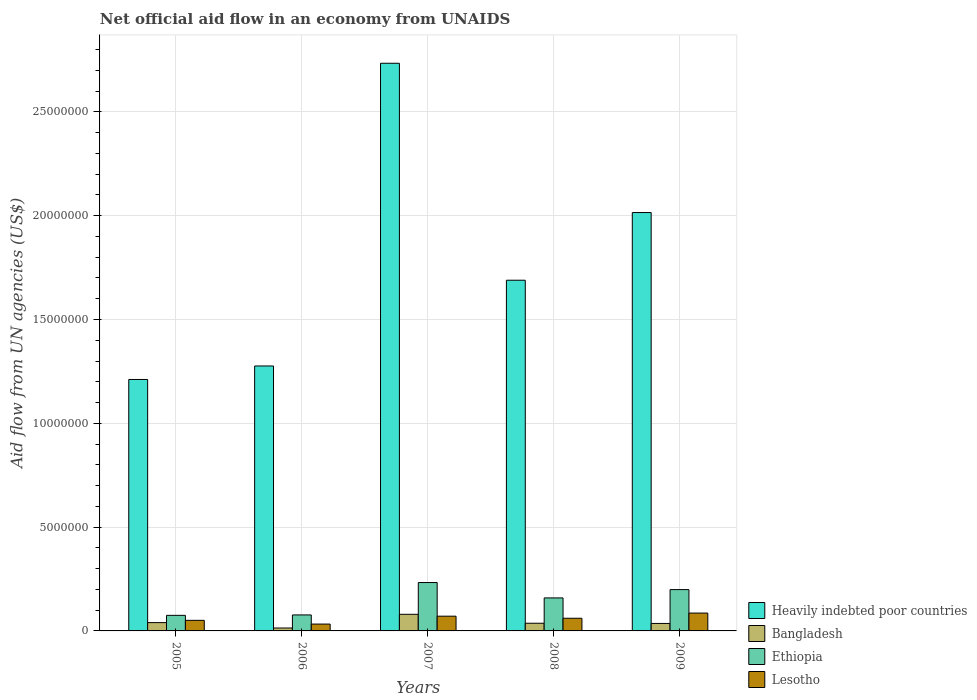What is the label of the 1st group of bars from the left?
Provide a short and direct response. 2005. In how many cases, is the number of bars for a given year not equal to the number of legend labels?
Your answer should be very brief. 0. What is the net official aid flow in Ethiopia in 2008?
Provide a short and direct response. 1.59e+06. Across all years, what is the maximum net official aid flow in Heavily indebted poor countries?
Give a very brief answer. 2.73e+07. Across all years, what is the minimum net official aid flow in Bangladesh?
Provide a succinct answer. 1.40e+05. In which year was the net official aid flow in Lesotho minimum?
Offer a terse response. 2006. What is the total net official aid flow in Heavily indebted poor countries in the graph?
Keep it short and to the point. 8.92e+07. What is the difference between the net official aid flow in Heavily indebted poor countries in 2005 and that in 2006?
Give a very brief answer. -6.50e+05. What is the difference between the net official aid flow in Heavily indebted poor countries in 2005 and the net official aid flow in Bangladesh in 2009?
Provide a short and direct response. 1.18e+07. What is the average net official aid flow in Lesotho per year?
Your answer should be very brief. 6.04e+05. In the year 2008, what is the difference between the net official aid flow in Heavily indebted poor countries and net official aid flow in Bangladesh?
Your answer should be very brief. 1.65e+07. In how many years, is the net official aid flow in Bangladesh greater than 13000000 US$?
Make the answer very short. 0. What is the ratio of the net official aid flow in Ethiopia in 2005 to that in 2009?
Offer a terse response. 0.38. Is the net official aid flow in Ethiopia in 2006 less than that in 2007?
Ensure brevity in your answer.  Yes. What is the difference between the highest and the second highest net official aid flow in Ethiopia?
Offer a terse response. 3.40e+05. What is the difference between the highest and the lowest net official aid flow in Ethiopia?
Your answer should be compact. 1.58e+06. Is the sum of the net official aid flow in Heavily indebted poor countries in 2005 and 2007 greater than the maximum net official aid flow in Lesotho across all years?
Offer a terse response. Yes. Is it the case that in every year, the sum of the net official aid flow in Heavily indebted poor countries and net official aid flow in Lesotho is greater than the sum of net official aid flow in Ethiopia and net official aid flow in Bangladesh?
Ensure brevity in your answer.  Yes. What does the 3rd bar from the left in 2005 represents?
Provide a short and direct response. Ethiopia. What does the 2nd bar from the right in 2006 represents?
Make the answer very short. Ethiopia. How many bars are there?
Provide a short and direct response. 20. What is the difference between two consecutive major ticks on the Y-axis?
Provide a succinct answer. 5.00e+06. Does the graph contain any zero values?
Offer a terse response. No. Does the graph contain grids?
Ensure brevity in your answer.  Yes. Where does the legend appear in the graph?
Provide a succinct answer. Bottom right. How are the legend labels stacked?
Offer a very short reply. Vertical. What is the title of the graph?
Keep it short and to the point. Net official aid flow in an economy from UNAIDS. Does "Guinea" appear as one of the legend labels in the graph?
Give a very brief answer. No. What is the label or title of the Y-axis?
Offer a very short reply. Aid flow from UN agencies (US$). What is the Aid flow from UN agencies (US$) in Heavily indebted poor countries in 2005?
Ensure brevity in your answer.  1.21e+07. What is the Aid flow from UN agencies (US$) of Bangladesh in 2005?
Provide a short and direct response. 4.00e+05. What is the Aid flow from UN agencies (US$) of Ethiopia in 2005?
Offer a terse response. 7.50e+05. What is the Aid flow from UN agencies (US$) in Lesotho in 2005?
Keep it short and to the point. 5.10e+05. What is the Aid flow from UN agencies (US$) in Heavily indebted poor countries in 2006?
Provide a succinct answer. 1.28e+07. What is the Aid flow from UN agencies (US$) in Ethiopia in 2006?
Offer a terse response. 7.70e+05. What is the Aid flow from UN agencies (US$) in Heavily indebted poor countries in 2007?
Offer a very short reply. 2.73e+07. What is the Aid flow from UN agencies (US$) of Ethiopia in 2007?
Your answer should be very brief. 2.33e+06. What is the Aid flow from UN agencies (US$) in Lesotho in 2007?
Provide a short and direct response. 7.10e+05. What is the Aid flow from UN agencies (US$) in Heavily indebted poor countries in 2008?
Provide a succinct answer. 1.69e+07. What is the Aid flow from UN agencies (US$) in Ethiopia in 2008?
Your response must be concise. 1.59e+06. What is the Aid flow from UN agencies (US$) in Lesotho in 2008?
Give a very brief answer. 6.10e+05. What is the Aid flow from UN agencies (US$) in Heavily indebted poor countries in 2009?
Make the answer very short. 2.02e+07. What is the Aid flow from UN agencies (US$) in Ethiopia in 2009?
Your response must be concise. 1.99e+06. What is the Aid flow from UN agencies (US$) of Lesotho in 2009?
Your answer should be very brief. 8.60e+05. Across all years, what is the maximum Aid flow from UN agencies (US$) of Heavily indebted poor countries?
Ensure brevity in your answer.  2.73e+07. Across all years, what is the maximum Aid flow from UN agencies (US$) in Ethiopia?
Your answer should be very brief. 2.33e+06. Across all years, what is the maximum Aid flow from UN agencies (US$) of Lesotho?
Your answer should be compact. 8.60e+05. Across all years, what is the minimum Aid flow from UN agencies (US$) in Heavily indebted poor countries?
Your answer should be compact. 1.21e+07. Across all years, what is the minimum Aid flow from UN agencies (US$) in Ethiopia?
Give a very brief answer. 7.50e+05. What is the total Aid flow from UN agencies (US$) of Heavily indebted poor countries in the graph?
Provide a succinct answer. 8.92e+07. What is the total Aid flow from UN agencies (US$) in Bangladesh in the graph?
Ensure brevity in your answer.  2.07e+06. What is the total Aid flow from UN agencies (US$) of Ethiopia in the graph?
Give a very brief answer. 7.43e+06. What is the total Aid flow from UN agencies (US$) of Lesotho in the graph?
Provide a succinct answer. 3.02e+06. What is the difference between the Aid flow from UN agencies (US$) in Heavily indebted poor countries in 2005 and that in 2006?
Ensure brevity in your answer.  -6.50e+05. What is the difference between the Aid flow from UN agencies (US$) in Bangladesh in 2005 and that in 2006?
Ensure brevity in your answer.  2.60e+05. What is the difference between the Aid flow from UN agencies (US$) in Ethiopia in 2005 and that in 2006?
Give a very brief answer. -2.00e+04. What is the difference between the Aid flow from UN agencies (US$) of Heavily indebted poor countries in 2005 and that in 2007?
Give a very brief answer. -1.52e+07. What is the difference between the Aid flow from UN agencies (US$) of Bangladesh in 2005 and that in 2007?
Keep it short and to the point. -4.00e+05. What is the difference between the Aid flow from UN agencies (US$) in Ethiopia in 2005 and that in 2007?
Your answer should be compact. -1.58e+06. What is the difference between the Aid flow from UN agencies (US$) in Lesotho in 2005 and that in 2007?
Provide a short and direct response. -2.00e+05. What is the difference between the Aid flow from UN agencies (US$) in Heavily indebted poor countries in 2005 and that in 2008?
Offer a very short reply. -4.78e+06. What is the difference between the Aid flow from UN agencies (US$) in Bangladesh in 2005 and that in 2008?
Your answer should be compact. 3.00e+04. What is the difference between the Aid flow from UN agencies (US$) in Ethiopia in 2005 and that in 2008?
Ensure brevity in your answer.  -8.40e+05. What is the difference between the Aid flow from UN agencies (US$) of Lesotho in 2005 and that in 2008?
Keep it short and to the point. -1.00e+05. What is the difference between the Aid flow from UN agencies (US$) in Heavily indebted poor countries in 2005 and that in 2009?
Ensure brevity in your answer.  -8.04e+06. What is the difference between the Aid flow from UN agencies (US$) of Ethiopia in 2005 and that in 2009?
Provide a succinct answer. -1.24e+06. What is the difference between the Aid flow from UN agencies (US$) of Lesotho in 2005 and that in 2009?
Give a very brief answer. -3.50e+05. What is the difference between the Aid flow from UN agencies (US$) of Heavily indebted poor countries in 2006 and that in 2007?
Keep it short and to the point. -1.46e+07. What is the difference between the Aid flow from UN agencies (US$) in Bangladesh in 2006 and that in 2007?
Offer a terse response. -6.60e+05. What is the difference between the Aid flow from UN agencies (US$) in Ethiopia in 2006 and that in 2007?
Provide a succinct answer. -1.56e+06. What is the difference between the Aid flow from UN agencies (US$) of Lesotho in 2006 and that in 2007?
Make the answer very short. -3.80e+05. What is the difference between the Aid flow from UN agencies (US$) in Heavily indebted poor countries in 2006 and that in 2008?
Your response must be concise. -4.13e+06. What is the difference between the Aid flow from UN agencies (US$) of Bangladesh in 2006 and that in 2008?
Your response must be concise. -2.30e+05. What is the difference between the Aid flow from UN agencies (US$) in Ethiopia in 2006 and that in 2008?
Make the answer very short. -8.20e+05. What is the difference between the Aid flow from UN agencies (US$) of Lesotho in 2006 and that in 2008?
Give a very brief answer. -2.80e+05. What is the difference between the Aid flow from UN agencies (US$) in Heavily indebted poor countries in 2006 and that in 2009?
Give a very brief answer. -7.39e+06. What is the difference between the Aid flow from UN agencies (US$) in Bangladesh in 2006 and that in 2009?
Offer a very short reply. -2.20e+05. What is the difference between the Aid flow from UN agencies (US$) in Ethiopia in 2006 and that in 2009?
Give a very brief answer. -1.22e+06. What is the difference between the Aid flow from UN agencies (US$) in Lesotho in 2006 and that in 2009?
Your response must be concise. -5.30e+05. What is the difference between the Aid flow from UN agencies (US$) of Heavily indebted poor countries in 2007 and that in 2008?
Provide a short and direct response. 1.04e+07. What is the difference between the Aid flow from UN agencies (US$) in Bangladesh in 2007 and that in 2008?
Make the answer very short. 4.30e+05. What is the difference between the Aid flow from UN agencies (US$) of Ethiopia in 2007 and that in 2008?
Your answer should be very brief. 7.40e+05. What is the difference between the Aid flow from UN agencies (US$) of Lesotho in 2007 and that in 2008?
Provide a short and direct response. 1.00e+05. What is the difference between the Aid flow from UN agencies (US$) in Heavily indebted poor countries in 2007 and that in 2009?
Your answer should be very brief. 7.19e+06. What is the difference between the Aid flow from UN agencies (US$) in Bangladesh in 2007 and that in 2009?
Make the answer very short. 4.40e+05. What is the difference between the Aid flow from UN agencies (US$) of Ethiopia in 2007 and that in 2009?
Provide a succinct answer. 3.40e+05. What is the difference between the Aid flow from UN agencies (US$) in Heavily indebted poor countries in 2008 and that in 2009?
Keep it short and to the point. -3.26e+06. What is the difference between the Aid flow from UN agencies (US$) of Bangladesh in 2008 and that in 2009?
Offer a terse response. 10000. What is the difference between the Aid flow from UN agencies (US$) of Ethiopia in 2008 and that in 2009?
Your answer should be very brief. -4.00e+05. What is the difference between the Aid flow from UN agencies (US$) of Heavily indebted poor countries in 2005 and the Aid flow from UN agencies (US$) of Bangladesh in 2006?
Your answer should be very brief. 1.20e+07. What is the difference between the Aid flow from UN agencies (US$) of Heavily indebted poor countries in 2005 and the Aid flow from UN agencies (US$) of Ethiopia in 2006?
Make the answer very short. 1.13e+07. What is the difference between the Aid flow from UN agencies (US$) in Heavily indebted poor countries in 2005 and the Aid flow from UN agencies (US$) in Lesotho in 2006?
Your answer should be compact. 1.18e+07. What is the difference between the Aid flow from UN agencies (US$) in Bangladesh in 2005 and the Aid flow from UN agencies (US$) in Ethiopia in 2006?
Your answer should be compact. -3.70e+05. What is the difference between the Aid flow from UN agencies (US$) in Heavily indebted poor countries in 2005 and the Aid flow from UN agencies (US$) in Bangladesh in 2007?
Provide a succinct answer. 1.13e+07. What is the difference between the Aid flow from UN agencies (US$) in Heavily indebted poor countries in 2005 and the Aid flow from UN agencies (US$) in Ethiopia in 2007?
Your response must be concise. 9.78e+06. What is the difference between the Aid flow from UN agencies (US$) of Heavily indebted poor countries in 2005 and the Aid flow from UN agencies (US$) of Lesotho in 2007?
Your answer should be very brief. 1.14e+07. What is the difference between the Aid flow from UN agencies (US$) of Bangladesh in 2005 and the Aid flow from UN agencies (US$) of Ethiopia in 2007?
Give a very brief answer. -1.93e+06. What is the difference between the Aid flow from UN agencies (US$) of Bangladesh in 2005 and the Aid flow from UN agencies (US$) of Lesotho in 2007?
Ensure brevity in your answer.  -3.10e+05. What is the difference between the Aid flow from UN agencies (US$) of Heavily indebted poor countries in 2005 and the Aid flow from UN agencies (US$) of Bangladesh in 2008?
Your answer should be compact. 1.17e+07. What is the difference between the Aid flow from UN agencies (US$) of Heavily indebted poor countries in 2005 and the Aid flow from UN agencies (US$) of Ethiopia in 2008?
Make the answer very short. 1.05e+07. What is the difference between the Aid flow from UN agencies (US$) of Heavily indebted poor countries in 2005 and the Aid flow from UN agencies (US$) of Lesotho in 2008?
Provide a short and direct response. 1.15e+07. What is the difference between the Aid flow from UN agencies (US$) in Bangladesh in 2005 and the Aid flow from UN agencies (US$) in Ethiopia in 2008?
Provide a succinct answer. -1.19e+06. What is the difference between the Aid flow from UN agencies (US$) of Bangladesh in 2005 and the Aid flow from UN agencies (US$) of Lesotho in 2008?
Ensure brevity in your answer.  -2.10e+05. What is the difference between the Aid flow from UN agencies (US$) of Ethiopia in 2005 and the Aid flow from UN agencies (US$) of Lesotho in 2008?
Ensure brevity in your answer.  1.40e+05. What is the difference between the Aid flow from UN agencies (US$) of Heavily indebted poor countries in 2005 and the Aid flow from UN agencies (US$) of Bangladesh in 2009?
Ensure brevity in your answer.  1.18e+07. What is the difference between the Aid flow from UN agencies (US$) of Heavily indebted poor countries in 2005 and the Aid flow from UN agencies (US$) of Ethiopia in 2009?
Keep it short and to the point. 1.01e+07. What is the difference between the Aid flow from UN agencies (US$) of Heavily indebted poor countries in 2005 and the Aid flow from UN agencies (US$) of Lesotho in 2009?
Make the answer very short. 1.12e+07. What is the difference between the Aid flow from UN agencies (US$) of Bangladesh in 2005 and the Aid flow from UN agencies (US$) of Ethiopia in 2009?
Keep it short and to the point. -1.59e+06. What is the difference between the Aid flow from UN agencies (US$) in Bangladesh in 2005 and the Aid flow from UN agencies (US$) in Lesotho in 2009?
Your response must be concise. -4.60e+05. What is the difference between the Aid flow from UN agencies (US$) in Heavily indebted poor countries in 2006 and the Aid flow from UN agencies (US$) in Bangladesh in 2007?
Offer a very short reply. 1.20e+07. What is the difference between the Aid flow from UN agencies (US$) in Heavily indebted poor countries in 2006 and the Aid flow from UN agencies (US$) in Ethiopia in 2007?
Your answer should be very brief. 1.04e+07. What is the difference between the Aid flow from UN agencies (US$) of Heavily indebted poor countries in 2006 and the Aid flow from UN agencies (US$) of Lesotho in 2007?
Your answer should be compact. 1.20e+07. What is the difference between the Aid flow from UN agencies (US$) of Bangladesh in 2006 and the Aid flow from UN agencies (US$) of Ethiopia in 2007?
Keep it short and to the point. -2.19e+06. What is the difference between the Aid flow from UN agencies (US$) of Bangladesh in 2006 and the Aid flow from UN agencies (US$) of Lesotho in 2007?
Offer a terse response. -5.70e+05. What is the difference between the Aid flow from UN agencies (US$) of Heavily indebted poor countries in 2006 and the Aid flow from UN agencies (US$) of Bangladesh in 2008?
Offer a very short reply. 1.24e+07. What is the difference between the Aid flow from UN agencies (US$) in Heavily indebted poor countries in 2006 and the Aid flow from UN agencies (US$) in Ethiopia in 2008?
Your answer should be very brief. 1.12e+07. What is the difference between the Aid flow from UN agencies (US$) of Heavily indebted poor countries in 2006 and the Aid flow from UN agencies (US$) of Lesotho in 2008?
Provide a succinct answer. 1.22e+07. What is the difference between the Aid flow from UN agencies (US$) in Bangladesh in 2006 and the Aid flow from UN agencies (US$) in Ethiopia in 2008?
Offer a terse response. -1.45e+06. What is the difference between the Aid flow from UN agencies (US$) of Bangladesh in 2006 and the Aid flow from UN agencies (US$) of Lesotho in 2008?
Your response must be concise. -4.70e+05. What is the difference between the Aid flow from UN agencies (US$) of Ethiopia in 2006 and the Aid flow from UN agencies (US$) of Lesotho in 2008?
Provide a succinct answer. 1.60e+05. What is the difference between the Aid flow from UN agencies (US$) of Heavily indebted poor countries in 2006 and the Aid flow from UN agencies (US$) of Bangladesh in 2009?
Give a very brief answer. 1.24e+07. What is the difference between the Aid flow from UN agencies (US$) in Heavily indebted poor countries in 2006 and the Aid flow from UN agencies (US$) in Ethiopia in 2009?
Offer a very short reply. 1.08e+07. What is the difference between the Aid flow from UN agencies (US$) of Heavily indebted poor countries in 2006 and the Aid flow from UN agencies (US$) of Lesotho in 2009?
Keep it short and to the point. 1.19e+07. What is the difference between the Aid flow from UN agencies (US$) of Bangladesh in 2006 and the Aid flow from UN agencies (US$) of Ethiopia in 2009?
Give a very brief answer. -1.85e+06. What is the difference between the Aid flow from UN agencies (US$) in Bangladesh in 2006 and the Aid flow from UN agencies (US$) in Lesotho in 2009?
Offer a very short reply. -7.20e+05. What is the difference between the Aid flow from UN agencies (US$) in Ethiopia in 2006 and the Aid flow from UN agencies (US$) in Lesotho in 2009?
Keep it short and to the point. -9.00e+04. What is the difference between the Aid flow from UN agencies (US$) in Heavily indebted poor countries in 2007 and the Aid flow from UN agencies (US$) in Bangladesh in 2008?
Your response must be concise. 2.70e+07. What is the difference between the Aid flow from UN agencies (US$) of Heavily indebted poor countries in 2007 and the Aid flow from UN agencies (US$) of Ethiopia in 2008?
Provide a succinct answer. 2.58e+07. What is the difference between the Aid flow from UN agencies (US$) in Heavily indebted poor countries in 2007 and the Aid flow from UN agencies (US$) in Lesotho in 2008?
Your answer should be compact. 2.67e+07. What is the difference between the Aid flow from UN agencies (US$) in Bangladesh in 2007 and the Aid flow from UN agencies (US$) in Ethiopia in 2008?
Your answer should be very brief. -7.90e+05. What is the difference between the Aid flow from UN agencies (US$) of Bangladesh in 2007 and the Aid flow from UN agencies (US$) of Lesotho in 2008?
Offer a very short reply. 1.90e+05. What is the difference between the Aid flow from UN agencies (US$) in Ethiopia in 2007 and the Aid flow from UN agencies (US$) in Lesotho in 2008?
Provide a succinct answer. 1.72e+06. What is the difference between the Aid flow from UN agencies (US$) in Heavily indebted poor countries in 2007 and the Aid flow from UN agencies (US$) in Bangladesh in 2009?
Offer a terse response. 2.70e+07. What is the difference between the Aid flow from UN agencies (US$) in Heavily indebted poor countries in 2007 and the Aid flow from UN agencies (US$) in Ethiopia in 2009?
Ensure brevity in your answer.  2.54e+07. What is the difference between the Aid flow from UN agencies (US$) in Heavily indebted poor countries in 2007 and the Aid flow from UN agencies (US$) in Lesotho in 2009?
Ensure brevity in your answer.  2.65e+07. What is the difference between the Aid flow from UN agencies (US$) in Bangladesh in 2007 and the Aid flow from UN agencies (US$) in Ethiopia in 2009?
Give a very brief answer. -1.19e+06. What is the difference between the Aid flow from UN agencies (US$) of Ethiopia in 2007 and the Aid flow from UN agencies (US$) of Lesotho in 2009?
Give a very brief answer. 1.47e+06. What is the difference between the Aid flow from UN agencies (US$) in Heavily indebted poor countries in 2008 and the Aid flow from UN agencies (US$) in Bangladesh in 2009?
Your answer should be compact. 1.65e+07. What is the difference between the Aid flow from UN agencies (US$) of Heavily indebted poor countries in 2008 and the Aid flow from UN agencies (US$) of Ethiopia in 2009?
Ensure brevity in your answer.  1.49e+07. What is the difference between the Aid flow from UN agencies (US$) in Heavily indebted poor countries in 2008 and the Aid flow from UN agencies (US$) in Lesotho in 2009?
Make the answer very short. 1.60e+07. What is the difference between the Aid flow from UN agencies (US$) in Bangladesh in 2008 and the Aid flow from UN agencies (US$) in Ethiopia in 2009?
Your answer should be very brief. -1.62e+06. What is the difference between the Aid flow from UN agencies (US$) of Bangladesh in 2008 and the Aid flow from UN agencies (US$) of Lesotho in 2009?
Make the answer very short. -4.90e+05. What is the difference between the Aid flow from UN agencies (US$) of Ethiopia in 2008 and the Aid flow from UN agencies (US$) of Lesotho in 2009?
Keep it short and to the point. 7.30e+05. What is the average Aid flow from UN agencies (US$) in Heavily indebted poor countries per year?
Keep it short and to the point. 1.78e+07. What is the average Aid flow from UN agencies (US$) in Bangladesh per year?
Make the answer very short. 4.14e+05. What is the average Aid flow from UN agencies (US$) of Ethiopia per year?
Your response must be concise. 1.49e+06. What is the average Aid flow from UN agencies (US$) in Lesotho per year?
Give a very brief answer. 6.04e+05. In the year 2005, what is the difference between the Aid flow from UN agencies (US$) in Heavily indebted poor countries and Aid flow from UN agencies (US$) in Bangladesh?
Give a very brief answer. 1.17e+07. In the year 2005, what is the difference between the Aid flow from UN agencies (US$) of Heavily indebted poor countries and Aid flow from UN agencies (US$) of Ethiopia?
Offer a terse response. 1.14e+07. In the year 2005, what is the difference between the Aid flow from UN agencies (US$) of Heavily indebted poor countries and Aid flow from UN agencies (US$) of Lesotho?
Ensure brevity in your answer.  1.16e+07. In the year 2005, what is the difference between the Aid flow from UN agencies (US$) in Bangladesh and Aid flow from UN agencies (US$) in Ethiopia?
Ensure brevity in your answer.  -3.50e+05. In the year 2005, what is the difference between the Aid flow from UN agencies (US$) of Bangladesh and Aid flow from UN agencies (US$) of Lesotho?
Ensure brevity in your answer.  -1.10e+05. In the year 2006, what is the difference between the Aid flow from UN agencies (US$) in Heavily indebted poor countries and Aid flow from UN agencies (US$) in Bangladesh?
Provide a succinct answer. 1.26e+07. In the year 2006, what is the difference between the Aid flow from UN agencies (US$) in Heavily indebted poor countries and Aid flow from UN agencies (US$) in Ethiopia?
Keep it short and to the point. 1.20e+07. In the year 2006, what is the difference between the Aid flow from UN agencies (US$) in Heavily indebted poor countries and Aid flow from UN agencies (US$) in Lesotho?
Provide a short and direct response. 1.24e+07. In the year 2006, what is the difference between the Aid flow from UN agencies (US$) of Bangladesh and Aid flow from UN agencies (US$) of Ethiopia?
Your answer should be very brief. -6.30e+05. In the year 2007, what is the difference between the Aid flow from UN agencies (US$) of Heavily indebted poor countries and Aid flow from UN agencies (US$) of Bangladesh?
Keep it short and to the point. 2.65e+07. In the year 2007, what is the difference between the Aid flow from UN agencies (US$) in Heavily indebted poor countries and Aid flow from UN agencies (US$) in Ethiopia?
Make the answer very short. 2.50e+07. In the year 2007, what is the difference between the Aid flow from UN agencies (US$) in Heavily indebted poor countries and Aid flow from UN agencies (US$) in Lesotho?
Make the answer very short. 2.66e+07. In the year 2007, what is the difference between the Aid flow from UN agencies (US$) in Bangladesh and Aid flow from UN agencies (US$) in Ethiopia?
Your answer should be compact. -1.53e+06. In the year 2007, what is the difference between the Aid flow from UN agencies (US$) in Ethiopia and Aid flow from UN agencies (US$) in Lesotho?
Keep it short and to the point. 1.62e+06. In the year 2008, what is the difference between the Aid flow from UN agencies (US$) of Heavily indebted poor countries and Aid flow from UN agencies (US$) of Bangladesh?
Keep it short and to the point. 1.65e+07. In the year 2008, what is the difference between the Aid flow from UN agencies (US$) of Heavily indebted poor countries and Aid flow from UN agencies (US$) of Ethiopia?
Provide a short and direct response. 1.53e+07. In the year 2008, what is the difference between the Aid flow from UN agencies (US$) of Heavily indebted poor countries and Aid flow from UN agencies (US$) of Lesotho?
Make the answer very short. 1.63e+07. In the year 2008, what is the difference between the Aid flow from UN agencies (US$) in Bangladesh and Aid flow from UN agencies (US$) in Ethiopia?
Your response must be concise. -1.22e+06. In the year 2008, what is the difference between the Aid flow from UN agencies (US$) in Bangladesh and Aid flow from UN agencies (US$) in Lesotho?
Offer a very short reply. -2.40e+05. In the year 2008, what is the difference between the Aid flow from UN agencies (US$) in Ethiopia and Aid flow from UN agencies (US$) in Lesotho?
Keep it short and to the point. 9.80e+05. In the year 2009, what is the difference between the Aid flow from UN agencies (US$) of Heavily indebted poor countries and Aid flow from UN agencies (US$) of Bangladesh?
Provide a succinct answer. 1.98e+07. In the year 2009, what is the difference between the Aid flow from UN agencies (US$) of Heavily indebted poor countries and Aid flow from UN agencies (US$) of Ethiopia?
Make the answer very short. 1.82e+07. In the year 2009, what is the difference between the Aid flow from UN agencies (US$) in Heavily indebted poor countries and Aid flow from UN agencies (US$) in Lesotho?
Offer a very short reply. 1.93e+07. In the year 2009, what is the difference between the Aid flow from UN agencies (US$) of Bangladesh and Aid flow from UN agencies (US$) of Ethiopia?
Offer a very short reply. -1.63e+06. In the year 2009, what is the difference between the Aid flow from UN agencies (US$) of Bangladesh and Aid flow from UN agencies (US$) of Lesotho?
Offer a very short reply. -5.00e+05. In the year 2009, what is the difference between the Aid flow from UN agencies (US$) in Ethiopia and Aid flow from UN agencies (US$) in Lesotho?
Make the answer very short. 1.13e+06. What is the ratio of the Aid flow from UN agencies (US$) of Heavily indebted poor countries in 2005 to that in 2006?
Give a very brief answer. 0.95. What is the ratio of the Aid flow from UN agencies (US$) of Bangladesh in 2005 to that in 2006?
Make the answer very short. 2.86. What is the ratio of the Aid flow from UN agencies (US$) of Lesotho in 2005 to that in 2006?
Your answer should be compact. 1.55. What is the ratio of the Aid flow from UN agencies (US$) in Heavily indebted poor countries in 2005 to that in 2007?
Keep it short and to the point. 0.44. What is the ratio of the Aid flow from UN agencies (US$) of Bangladesh in 2005 to that in 2007?
Make the answer very short. 0.5. What is the ratio of the Aid flow from UN agencies (US$) of Ethiopia in 2005 to that in 2007?
Give a very brief answer. 0.32. What is the ratio of the Aid flow from UN agencies (US$) of Lesotho in 2005 to that in 2007?
Give a very brief answer. 0.72. What is the ratio of the Aid flow from UN agencies (US$) in Heavily indebted poor countries in 2005 to that in 2008?
Offer a very short reply. 0.72. What is the ratio of the Aid flow from UN agencies (US$) in Bangladesh in 2005 to that in 2008?
Provide a short and direct response. 1.08. What is the ratio of the Aid flow from UN agencies (US$) in Ethiopia in 2005 to that in 2008?
Ensure brevity in your answer.  0.47. What is the ratio of the Aid flow from UN agencies (US$) in Lesotho in 2005 to that in 2008?
Your answer should be very brief. 0.84. What is the ratio of the Aid flow from UN agencies (US$) in Heavily indebted poor countries in 2005 to that in 2009?
Keep it short and to the point. 0.6. What is the ratio of the Aid flow from UN agencies (US$) in Ethiopia in 2005 to that in 2009?
Give a very brief answer. 0.38. What is the ratio of the Aid flow from UN agencies (US$) in Lesotho in 2005 to that in 2009?
Offer a very short reply. 0.59. What is the ratio of the Aid flow from UN agencies (US$) in Heavily indebted poor countries in 2006 to that in 2007?
Keep it short and to the point. 0.47. What is the ratio of the Aid flow from UN agencies (US$) in Bangladesh in 2006 to that in 2007?
Your answer should be compact. 0.17. What is the ratio of the Aid flow from UN agencies (US$) of Ethiopia in 2006 to that in 2007?
Provide a short and direct response. 0.33. What is the ratio of the Aid flow from UN agencies (US$) in Lesotho in 2006 to that in 2007?
Make the answer very short. 0.46. What is the ratio of the Aid flow from UN agencies (US$) in Heavily indebted poor countries in 2006 to that in 2008?
Offer a very short reply. 0.76. What is the ratio of the Aid flow from UN agencies (US$) in Bangladesh in 2006 to that in 2008?
Your answer should be compact. 0.38. What is the ratio of the Aid flow from UN agencies (US$) in Ethiopia in 2006 to that in 2008?
Provide a succinct answer. 0.48. What is the ratio of the Aid flow from UN agencies (US$) of Lesotho in 2006 to that in 2008?
Provide a succinct answer. 0.54. What is the ratio of the Aid flow from UN agencies (US$) in Heavily indebted poor countries in 2006 to that in 2009?
Your answer should be very brief. 0.63. What is the ratio of the Aid flow from UN agencies (US$) of Bangladesh in 2006 to that in 2009?
Make the answer very short. 0.39. What is the ratio of the Aid flow from UN agencies (US$) in Ethiopia in 2006 to that in 2009?
Your answer should be very brief. 0.39. What is the ratio of the Aid flow from UN agencies (US$) of Lesotho in 2006 to that in 2009?
Offer a terse response. 0.38. What is the ratio of the Aid flow from UN agencies (US$) in Heavily indebted poor countries in 2007 to that in 2008?
Offer a very short reply. 1.62. What is the ratio of the Aid flow from UN agencies (US$) in Bangladesh in 2007 to that in 2008?
Offer a very short reply. 2.16. What is the ratio of the Aid flow from UN agencies (US$) in Ethiopia in 2007 to that in 2008?
Provide a succinct answer. 1.47. What is the ratio of the Aid flow from UN agencies (US$) of Lesotho in 2007 to that in 2008?
Offer a terse response. 1.16. What is the ratio of the Aid flow from UN agencies (US$) in Heavily indebted poor countries in 2007 to that in 2009?
Offer a very short reply. 1.36. What is the ratio of the Aid flow from UN agencies (US$) in Bangladesh in 2007 to that in 2009?
Ensure brevity in your answer.  2.22. What is the ratio of the Aid flow from UN agencies (US$) of Ethiopia in 2007 to that in 2009?
Provide a short and direct response. 1.17. What is the ratio of the Aid flow from UN agencies (US$) in Lesotho in 2007 to that in 2009?
Provide a short and direct response. 0.83. What is the ratio of the Aid flow from UN agencies (US$) of Heavily indebted poor countries in 2008 to that in 2009?
Provide a succinct answer. 0.84. What is the ratio of the Aid flow from UN agencies (US$) in Bangladesh in 2008 to that in 2009?
Provide a short and direct response. 1.03. What is the ratio of the Aid flow from UN agencies (US$) in Ethiopia in 2008 to that in 2009?
Give a very brief answer. 0.8. What is the ratio of the Aid flow from UN agencies (US$) in Lesotho in 2008 to that in 2009?
Keep it short and to the point. 0.71. What is the difference between the highest and the second highest Aid flow from UN agencies (US$) in Heavily indebted poor countries?
Keep it short and to the point. 7.19e+06. What is the difference between the highest and the second highest Aid flow from UN agencies (US$) in Ethiopia?
Your response must be concise. 3.40e+05. What is the difference between the highest and the lowest Aid flow from UN agencies (US$) of Heavily indebted poor countries?
Your response must be concise. 1.52e+07. What is the difference between the highest and the lowest Aid flow from UN agencies (US$) of Bangladesh?
Make the answer very short. 6.60e+05. What is the difference between the highest and the lowest Aid flow from UN agencies (US$) in Ethiopia?
Ensure brevity in your answer.  1.58e+06. What is the difference between the highest and the lowest Aid flow from UN agencies (US$) in Lesotho?
Ensure brevity in your answer.  5.30e+05. 